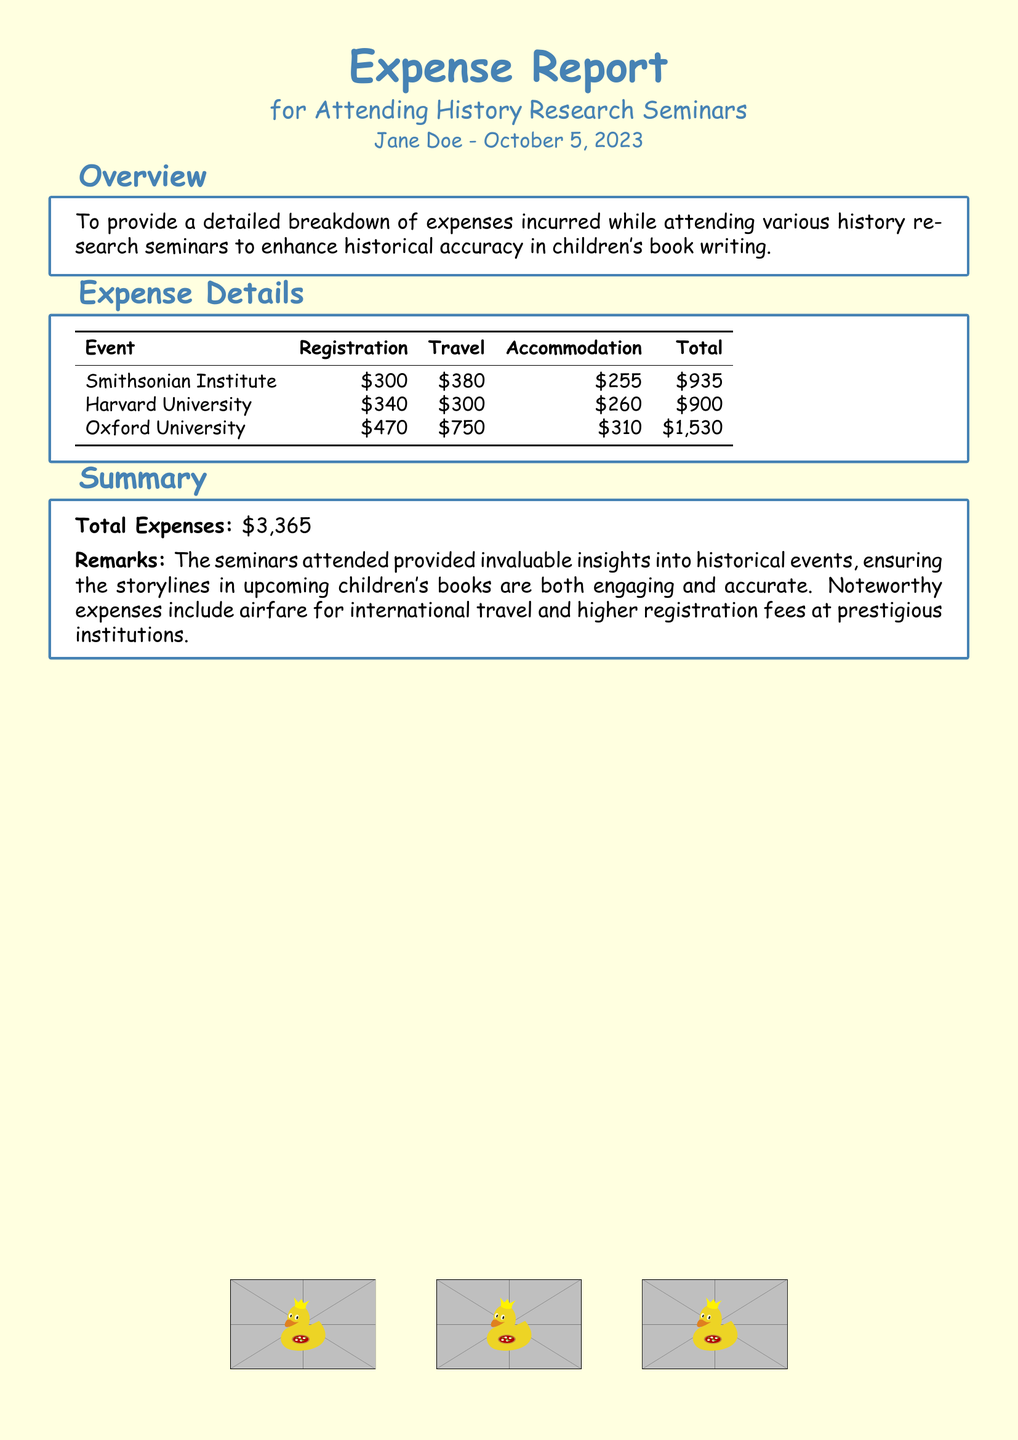What is the title of the report? The title is prominently displayed at the top of the document, stating the purpose of the report.
Answer: Expense Report Who is the author of the report? The author’s name is mentioned at the start of the document, underneath the title.
Answer: Jane Doe What is the date of the report? The date is provided along with the author's name, indicating when the report was prepared.
Answer: October 5, 2023 What is the total amount spent on attending seminars? The total expenses are calculated and presented in the summary section of the document.
Answer: $3,365 Which university had the highest total expenses? By comparing the total expenses listed for each university, it can be determined which had the highest amount.
Answer: Oxford University What was the registration fee for the Smithsonian Institute event? The registration fee is listed alongside other expenses in the detail table of events attended.
Answer: $300 What is the accommodation cost for the Harvard University seminar? The accommodation cost is provided in the expense details for that specific event.
Answer: $260 How many seminars are listed in the expense details? Counting the events listed under the expense details section gives the total number of seminars.
Answer: 3 What are the remarks about the seminars attended? The summary section contains remarks detailing the insights gained from attending the seminars.
Answer: Invaluable insights into historical events What color is used for the document background? The document background color is mentioned in the style settings, relevant for visual presentation.
Answer: Light yellow 